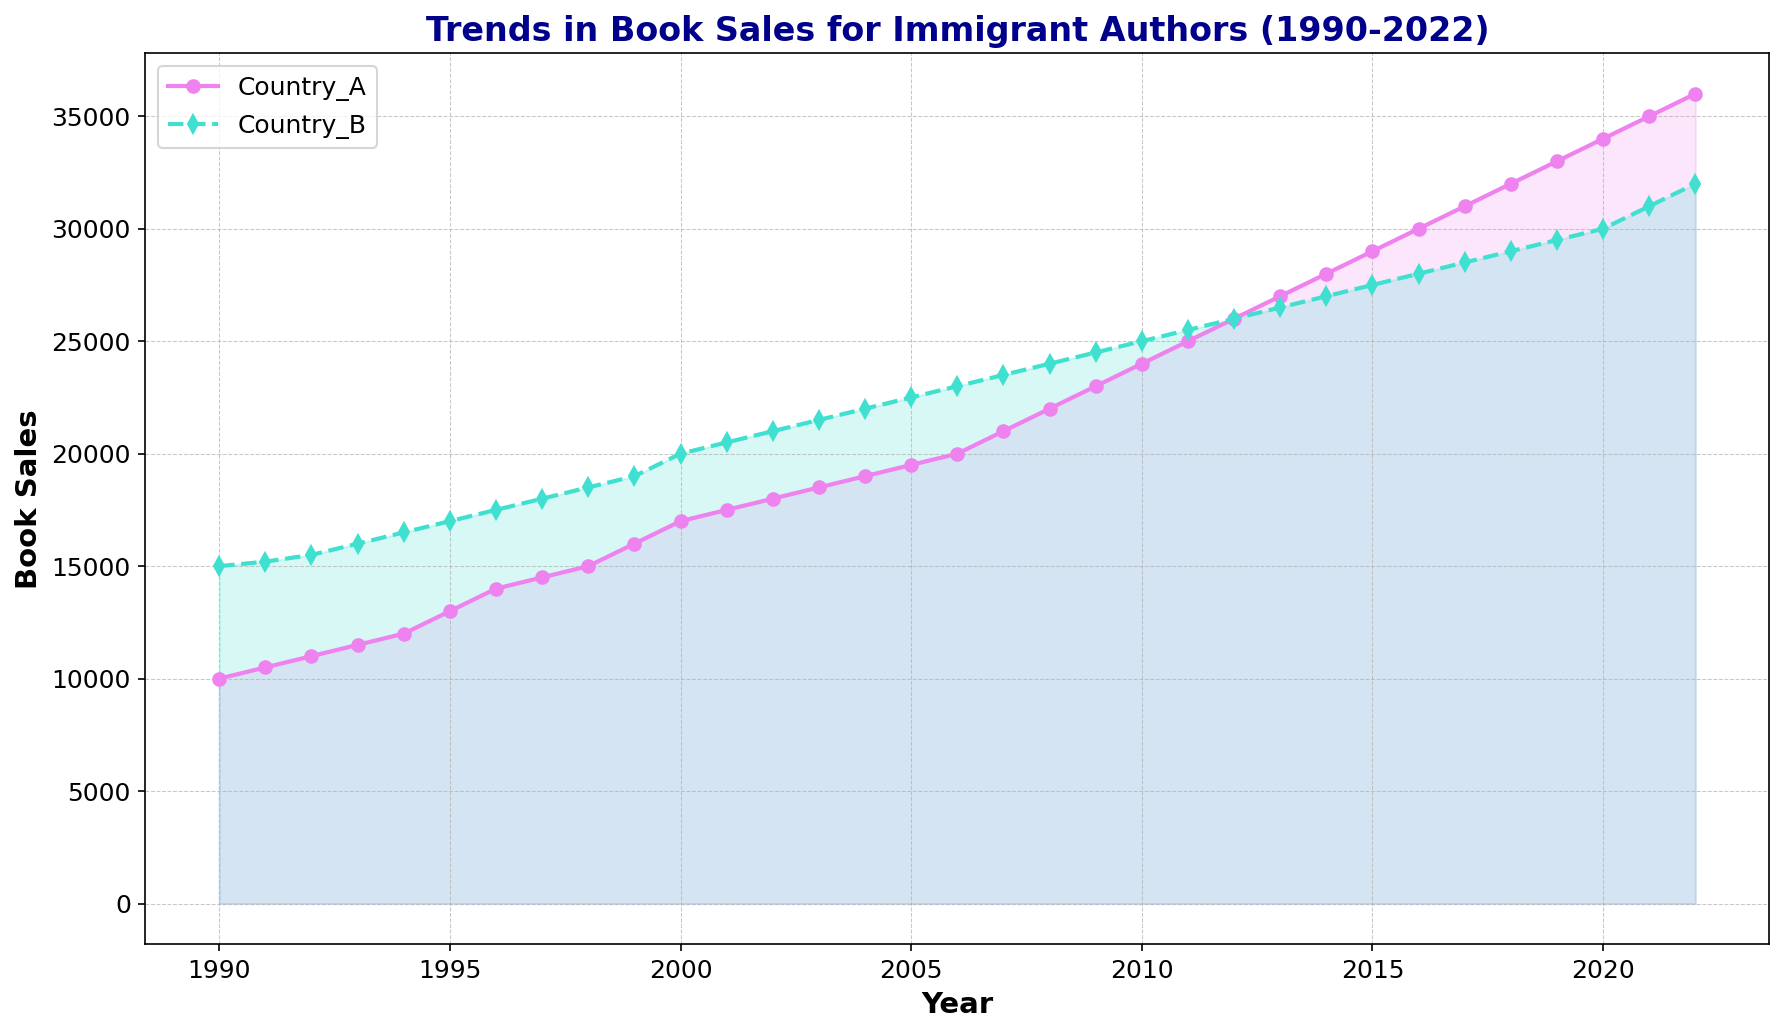What trend can be observed in the book sales of authors from Country A over the three decades? Observing the line chart, the book sales for authors from Country A show a steady and consistent upward trend from 1990 to 2022, starting at 10,000 in 1990 and ending at 36,000 in 2022.
Answer: upward trend How do the book sales in 2022 for Country A compare to those for Country B? Looking at the figure, the book sales for Country A in 2022 are 36,000, while for Country B they are 32,000. Therefore, book sales for Country A in 2022 are higher than those for Country B.
Answer: Country A > Country B What was the difference in book sales between Country A and Country B in the year 2000? In the year 2000, the figure shows that Country A had book sales of 17,000, whereas Country B had book sales of 20,000. The difference is 20,000 - 17,000 = 3,000.
Answer: 3,000 What year did book sales for Country A and Country B first become equal? The figure shows both Country A and Country B had equal book sales of 26,000 in the year 2012.
Answer: 2012 How much did book sales increase for Country A from 1995 to 2005? According to the figure, book sales for Country A were 13,000 in 1995 and increased to 19,500 in 2005. The increase is calculated as 19,500 - 13,000 = 6,500.
Answer: 6,500 What's the average book sales for Country B over the period from 2012 to 2015? From the figure, the book sales for Country B from 2012 to 2015 are as follows: 2012: 26,000, 2013: 26,500, 2014: 27,000, 2015: 27,500. The average is calculated as (26,000 + 26,500 + 27,000 + 27,500) / 4 = 26,750.
Answer: 26,750 Between 1997 and 2010, how many years did book sales for Country A increase consecutively? From the figure, book sales for Country A increased every year from 1997 (14,500) to 2010 (24,000). This is a consecutive increase over 13 years.
Answer: 13 years What is the general relationship between the trends of book sales in Country A and Country B over the decades? The figure shows that both Country A and Country B have an overall upward trend in book sales, but Country A's increase is steeper and more consistent, whereas Country B had a more gradual increase with a slight plateau around 2011-2015.
Answer: Upward trends with Country A steeper What is the visual difference in the representation of book sales data for Country A and Country B? Visually, the book sales data for Country A is represented with a violet line with 'o' markers and a shaded area, while Country B is represented with a turquoise dashed line with 'd' markers and a similarly shaded area.
Answer: Violet vs Turquoise lines 